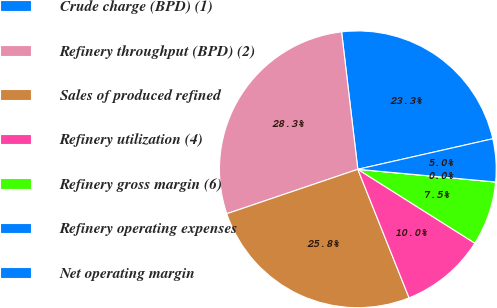<chart> <loc_0><loc_0><loc_500><loc_500><pie_chart><fcel>Crude charge (BPD) (1)<fcel>Refinery throughput (BPD) (2)<fcel>Sales of produced refined<fcel>Refinery utilization (4)<fcel>Refinery gross margin (6)<fcel>Refinery operating expenses<fcel>Net operating margin<nl><fcel>23.33%<fcel>28.33%<fcel>25.83%<fcel>10.0%<fcel>7.5%<fcel>0.0%<fcel>5.0%<nl></chart> 